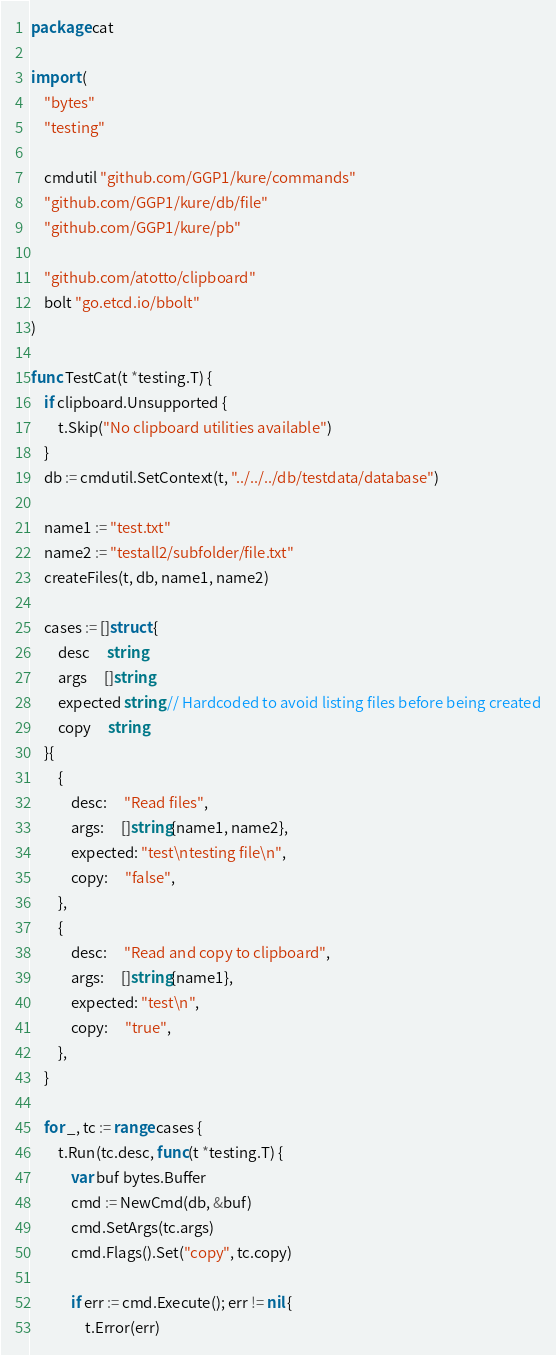Convert code to text. <code><loc_0><loc_0><loc_500><loc_500><_Go_>package cat

import (
	"bytes"
	"testing"

	cmdutil "github.com/GGP1/kure/commands"
	"github.com/GGP1/kure/db/file"
	"github.com/GGP1/kure/pb"

	"github.com/atotto/clipboard"
	bolt "go.etcd.io/bbolt"
)

func TestCat(t *testing.T) {
	if clipboard.Unsupported {
		t.Skip("No clipboard utilities available")
	}
	db := cmdutil.SetContext(t, "../../../db/testdata/database")

	name1 := "test.txt"
	name2 := "testall2/subfolder/file.txt"
	createFiles(t, db, name1, name2)

	cases := []struct {
		desc     string
		args     []string
		expected string // Hardcoded to avoid listing files before being created
		copy     string
	}{
		{
			desc:     "Read files",
			args:     []string{name1, name2},
			expected: "test\ntesting file\n",
			copy:     "false",
		},
		{
			desc:     "Read and copy to clipboard",
			args:     []string{name1},
			expected: "test\n",
			copy:     "true",
		},
	}

	for _, tc := range cases {
		t.Run(tc.desc, func(t *testing.T) {
			var buf bytes.Buffer
			cmd := NewCmd(db, &buf)
			cmd.SetArgs(tc.args)
			cmd.Flags().Set("copy", tc.copy)

			if err := cmd.Execute(); err != nil {
				t.Error(err)</code> 